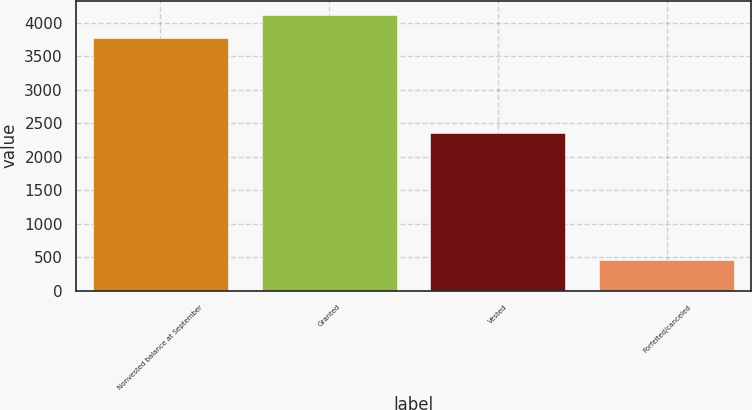<chart> <loc_0><loc_0><loc_500><loc_500><bar_chart><fcel>Nonvested balance at September<fcel>Granted<fcel>Vested<fcel>Forfeited/canceled<nl><fcel>3778<fcel>4122.7<fcel>2347<fcel>459<nl></chart> 